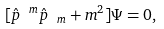<formula> <loc_0><loc_0><loc_500><loc_500>[ { \hat { p } } ^ { \ m } { \hat { p } } _ { \ m } + m ^ { 2 } ] \Psi = 0 ,</formula> 